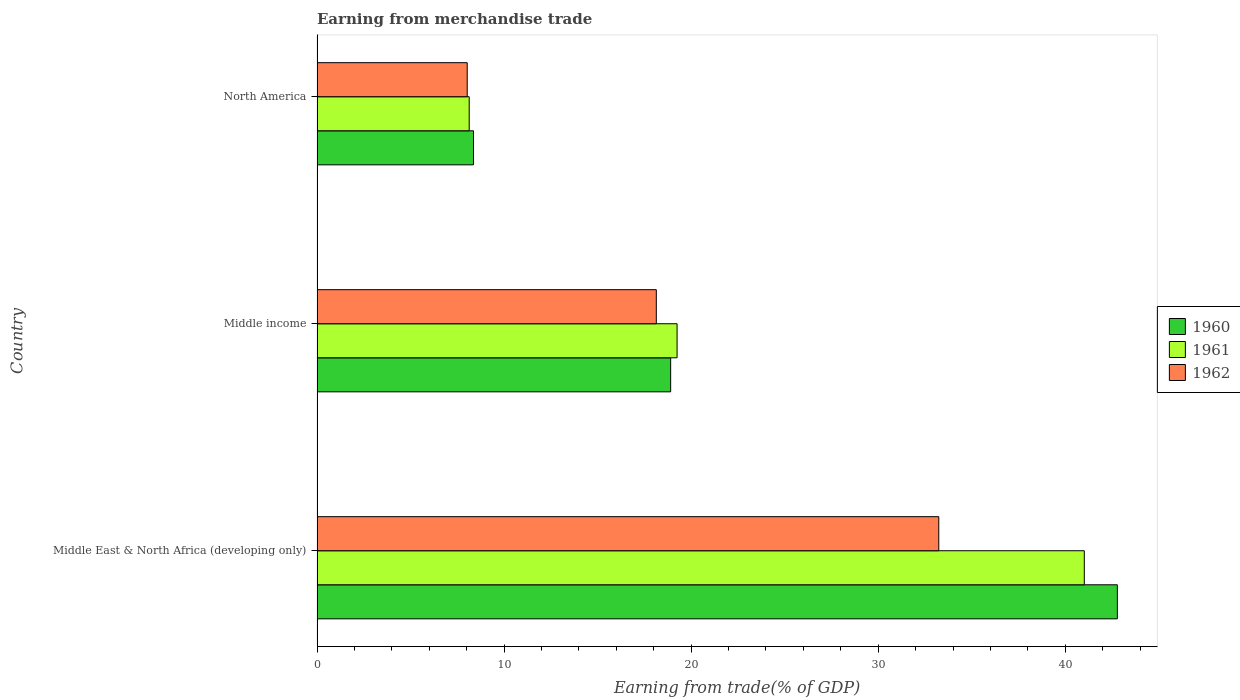How many different coloured bars are there?
Your answer should be compact. 3. Are the number of bars on each tick of the Y-axis equal?
Provide a succinct answer. Yes. What is the label of the 3rd group of bars from the top?
Offer a very short reply. Middle East & North Africa (developing only). In how many cases, is the number of bars for a given country not equal to the number of legend labels?
Offer a very short reply. 0. What is the earnings from trade in 1960 in Middle East & North Africa (developing only)?
Your answer should be very brief. 42.78. Across all countries, what is the maximum earnings from trade in 1962?
Make the answer very short. 33.24. Across all countries, what is the minimum earnings from trade in 1960?
Keep it short and to the point. 8.36. In which country was the earnings from trade in 1961 maximum?
Make the answer very short. Middle East & North Africa (developing only). What is the total earnings from trade in 1961 in the graph?
Provide a short and direct response. 68.4. What is the difference between the earnings from trade in 1960 in Middle East & North Africa (developing only) and that in Middle income?
Make the answer very short. 23.88. What is the difference between the earnings from trade in 1960 in North America and the earnings from trade in 1962 in Middle East & North Africa (developing only)?
Ensure brevity in your answer.  -24.87. What is the average earnings from trade in 1961 per country?
Offer a terse response. 22.8. What is the difference between the earnings from trade in 1960 and earnings from trade in 1961 in Middle East & North Africa (developing only)?
Your answer should be compact. 1.77. In how many countries, is the earnings from trade in 1962 greater than 24 %?
Make the answer very short. 1. What is the ratio of the earnings from trade in 1962 in Middle East & North Africa (developing only) to that in North America?
Your answer should be very brief. 4.14. Is the earnings from trade in 1960 in Middle income less than that in North America?
Provide a succinct answer. No. What is the difference between the highest and the second highest earnings from trade in 1962?
Your answer should be compact. 15.1. What is the difference between the highest and the lowest earnings from trade in 1960?
Provide a short and direct response. 34.42. Is the sum of the earnings from trade in 1962 in Middle East & North Africa (developing only) and North America greater than the maximum earnings from trade in 1960 across all countries?
Offer a very short reply. No. What does the 3rd bar from the top in Middle East & North Africa (developing only) represents?
Offer a very short reply. 1960. How many bars are there?
Give a very brief answer. 9. Are all the bars in the graph horizontal?
Offer a terse response. Yes. How many countries are there in the graph?
Give a very brief answer. 3. Are the values on the major ticks of X-axis written in scientific E-notation?
Provide a succinct answer. No. Does the graph contain any zero values?
Your response must be concise. No. Where does the legend appear in the graph?
Ensure brevity in your answer.  Center right. How are the legend labels stacked?
Your answer should be compact. Vertical. What is the title of the graph?
Make the answer very short. Earning from merchandise trade. What is the label or title of the X-axis?
Give a very brief answer. Earning from trade(% of GDP). What is the label or title of the Y-axis?
Ensure brevity in your answer.  Country. What is the Earning from trade(% of GDP) of 1960 in Middle East & North Africa (developing only)?
Ensure brevity in your answer.  42.78. What is the Earning from trade(% of GDP) of 1961 in Middle East & North Africa (developing only)?
Provide a succinct answer. 41.02. What is the Earning from trade(% of GDP) in 1962 in Middle East & North Africa (developing only)?
Offer a very short reply. 33.24. What is the Earning from trade(% of GDP) of 1960 in Middle income?
Your answer should be very brief. 18.9. What is the Earning from trade(% of GDP) of 1961 in Middle income?
Make the answer very short. 19.25. What is the Earning from trade(% of GDP) in 1962 in Middle income?
Offer a very short reply. 18.14. What is the Earning from trade(% of GDP) in 1960 in North America?
Give a very brief answer. 8.36. What is the Earning from trade(% of GDP) of 1961 in North America?
Ensure brevity in your answer.  8.13. What is the Earning from trade(% of GDP) in 1962 in North America?
Offer a terse response. 8.03. Across all countries, what is the maximum Earning from trade(% of GDP) of 1960?
Provide a short and direct response. 42.78. Across all countries, what is the maximum Earning from trade(% of GDP) of 1961?
Offer a very short reply. 41.02. Across all countries, what is the maximum Earning from trade(% of GDP) in 1962?
Ensure brevity in your answer.  33.24. Across all countries, what is the minimum Earning from trade(% of GDP) of 1960?
Offer a very short reply. 8.36. Across all countries, what is the minimum Earning from trade(% of GDP) in 1961?
Keep it short and to the point. 8.13. Across all countries, what is the minimum Earning from trade(% of GDP) of 1962?
Your answer should be very brief. 8.03. What is the total Earning from trade(% of GDP) in 1960 in the graph?
Make the answer very short. 70.05. What is the total Earning from trade(% of GDP) in 1961 in the graph?
Offer a terse response. 68.4. What is the total Earning from trade(% of GDP) of 1962 in the graph?
Offer a terse response. 59.4. What is the difference between the Earning from trade(% of GDP) in 1960 in Middle East & North Africa (developing only) and that in Middle income?
Offer a terse response. 23.88. What is the difference between the Earning from trade(% of GDP) in 1961 in Middle East & North Africa (developing only) and that in Middle income?
Offer a very short reply. 21.77. What is the difference between the Earning from trade(% of GDP) in 1962 in Middle East & North Africa (developing only) and that in Middle income?
Ensure brevity in your answer.  15.1. What is the difference between the Earning from trade(% of GDP) of 1960 in Middle East & North Africa (developing only) and that in North America?
Your response must be concise. 34.42. What is the difference between the Earning from trade(% of GDP) of 1961 in Middle East & North Africa (developing only) and that in North America?
Give a very brief answer. 32.88. What is the difference between the Earning from trade(% of GDP) of 1962 in Middle East & North Africa (developing only) and that in North America?
Ensure brevity in your answer.  25.21. What is the difference between the Earning from trade(% of GDP) in 1960 in Middle income and that in North America?
Your answer should be very brief. 10.54. What is the difference between the Earning from trade(% of GDP) of 1961 in Middle income and that in North America?
Give a very brief answer. 11.11. What is the difference between the Earning from trade(% of GDP) in 1962 in Middle income and that in North America?
Your response must be concise. 10.11. What is the difference between the Earning from trade(% of GDP) of 1960 in Middle East & North Africa (developing only) and the Earning from trade(% of GDP) of 1961 in Middle income?
Offer a very short reply. 23.54. What is the difference between the Earning from trade(% of GDP) in 1960 in Middle East & North Africa (developing only) and the Earning from trade(% of GDP) in 1962 in Middle income?
Your response must be concise. 24.65. What is the difference between the Earning from trade(% of GDP) in 1961 in Middle East & North Africa (developing only) and the Earning from trade(% of GDP) in 1962 in Middle income?
Your answer should be very brief. 22.88. What is the difference between the Earning from trade(% of GDP) of 1960 in Middle East & North Africa (developing only) and the Earning from trade(% of GDP) of 1961 in North America?
Offer a terse response. 34.65. What is the difference between the Earning from trade(% of GDP) of 1960 in Middle East & North Africa (developing only) and the Earning from trade(% of GDP) of 1962 in North America?
Offer a very short reply. 34.76. What is the difference between the Earning from trade(% of GDP) of 1961 in Middle East & North Africa (developing only) and the Earning from trade(% of GDP) of 1962 in North America?
Your answer should be very brief. 32.99. What is the difference between the Earning from trade(% of GDP) in 1960 in Middle income and the Earning from trade(% of GDP) in 1961 in North America?
Provide a short and direct response. 10.77. What is the difference between the Earning from trade(% of GDP) of 1960 in Middle income and the Earning from trade(% of GDP) of 1962 in North America?
Keep it short and to the point. 10.88. What is the difference between the Earning from trade(% of GDP) of 1961 in Middle income and the Earning from trade(% of GDP) of 1962 in North America?
Your answer should be very brief. 11.22. What is the average Earning from trade(% of GDP) of 1960 per country?
Make the answer very short. 23.35. What is the average Earning from trade(% of GDP) of 1961 per country?
Your answer should be very brief. 22.8. What is the average Earning from trade(% of GDP) in 1962 per country?
Give a very brief answer. 19.8. What is the difference between the Earning from trade(% of GDP) in 1960 and Earning from trade(% of GDP) in 1961 in Middle East & North Africa (developing only)?
Keep it short and to the point. 1.77. What is the difference between the Earning from trade(% of GDP) of 1960 and Earning from trade(% of GDP) of 1962 in Middle East & North Africa (developing only)?
Offer a very short reply. 9.55. What is the difference between the Earning from trade(% of GDP) of 1961 and Earning from trade(% of GDP) of 1962 in Middle East & North Africa (developing only)?
Make the answer very short. 7.78. What is the difference between the Earning from trade(% of GDP) of 1960 and Earning from trade(% of GDP) of 1961 in Middle income?
Your answer should be compact. -0.34. What is the difference between the Earning from trade(% of GDP) in 1960 and Earning from trade(% of GDP) in 1962 in Middle income?
Ensure brevity in your answer.  0.77. What is the difference between the Earning from trade(% of GDP) in 1961 and Earning from trade(% of GDP) in 1962 in Middle income?
Ensure brevity in your answer.  1.11. What is the difference between the Earning from trade(% of GDP) in 1960 and Earning from trade(% of GDP) in 1961 in North America?
Your answer should be compact. 0.23. What is the difference between the Earning from trade(% of GDP) in 1960 and Earning from trade(% of GDP) in 1962 in North America?
Your answer should be compact. 0.33. What is the difference between the Earning from trade(% of GDP) in 1961 and Earning from trade(% of GDP) in 1962 in North America?
Ensure brevity in your answer.  0.11. What is the ratio of the Earning from trade(% of GDP) of 1960 in Middle East & North Africa (developing only) to that in Middle income?
Ensure brevity in your answer.  2.26. What is the ratio of the Earning from trade(% of GDP) of 1961 in Middle East & North Africa (developing only) to that in Middle income?
Your response must be concise. 2.13. What is the ratio of the Earning from trade(% of GDP) in 1962 in Middle East & North Africa (developing only) to that in Middle income?
Provide a short and direct response. 1.83. What is the ratio of the Earning from trade(% of GDP) in 1960 in Middle East & North Africa (developing only) to that in North America?
Your answer should be compact. 5.12. What is the ratio of the Earning from trade(% of GDP) in 1961 in Middle East & North Africa (developing only) to that in North America?
Ensure brevity in your answer.  5.04. What is the ratio of the Earning from trade(% of GDP) of 1962 in Middle East & North Africa (developing only) to that in North America?
Ensure brevity in your answer.  4.14. What is the ratio of the Earning from trade(% of GDP) of 1960 in Middle income to that in North America?
Your answer should be very brief. 2.26. What is the ratio of the Earning from trade(% of GDP) in 1961 in Middle income to that in North America?
Offer a very short reply. 2.37. What is the ratio of the Earning from trade(% of GDP) in 1962 in Middle income to that in North America?
Provide a succinct answer. 2.26. What is the difference between the highest and the second highest Earning from trade(% of GDP) in 1960?
Provide a short and direct response. 23.88. What is the difference between the highest and the second highest Earning from trade(% of GDP) in 1961?
Offer a terse response. 21.77. What is the difference between the highest and the second highest Earning from trade(% of GDP) of 1962?
Keep it short and to the point. 15.1. What is the difference between the highest and the lowest Earning from trade(% of GDP) of 1960?
Your response must be concise. 34.42. What is the difference between the highest and the lowest Earning from trade(% of GDP) in 1961?
Your answer should be compact. 32.88. What is the difference between the highest and the lowest Earning from trade(% of GDP) in 1962?
Offer a terse response. 25.21. 